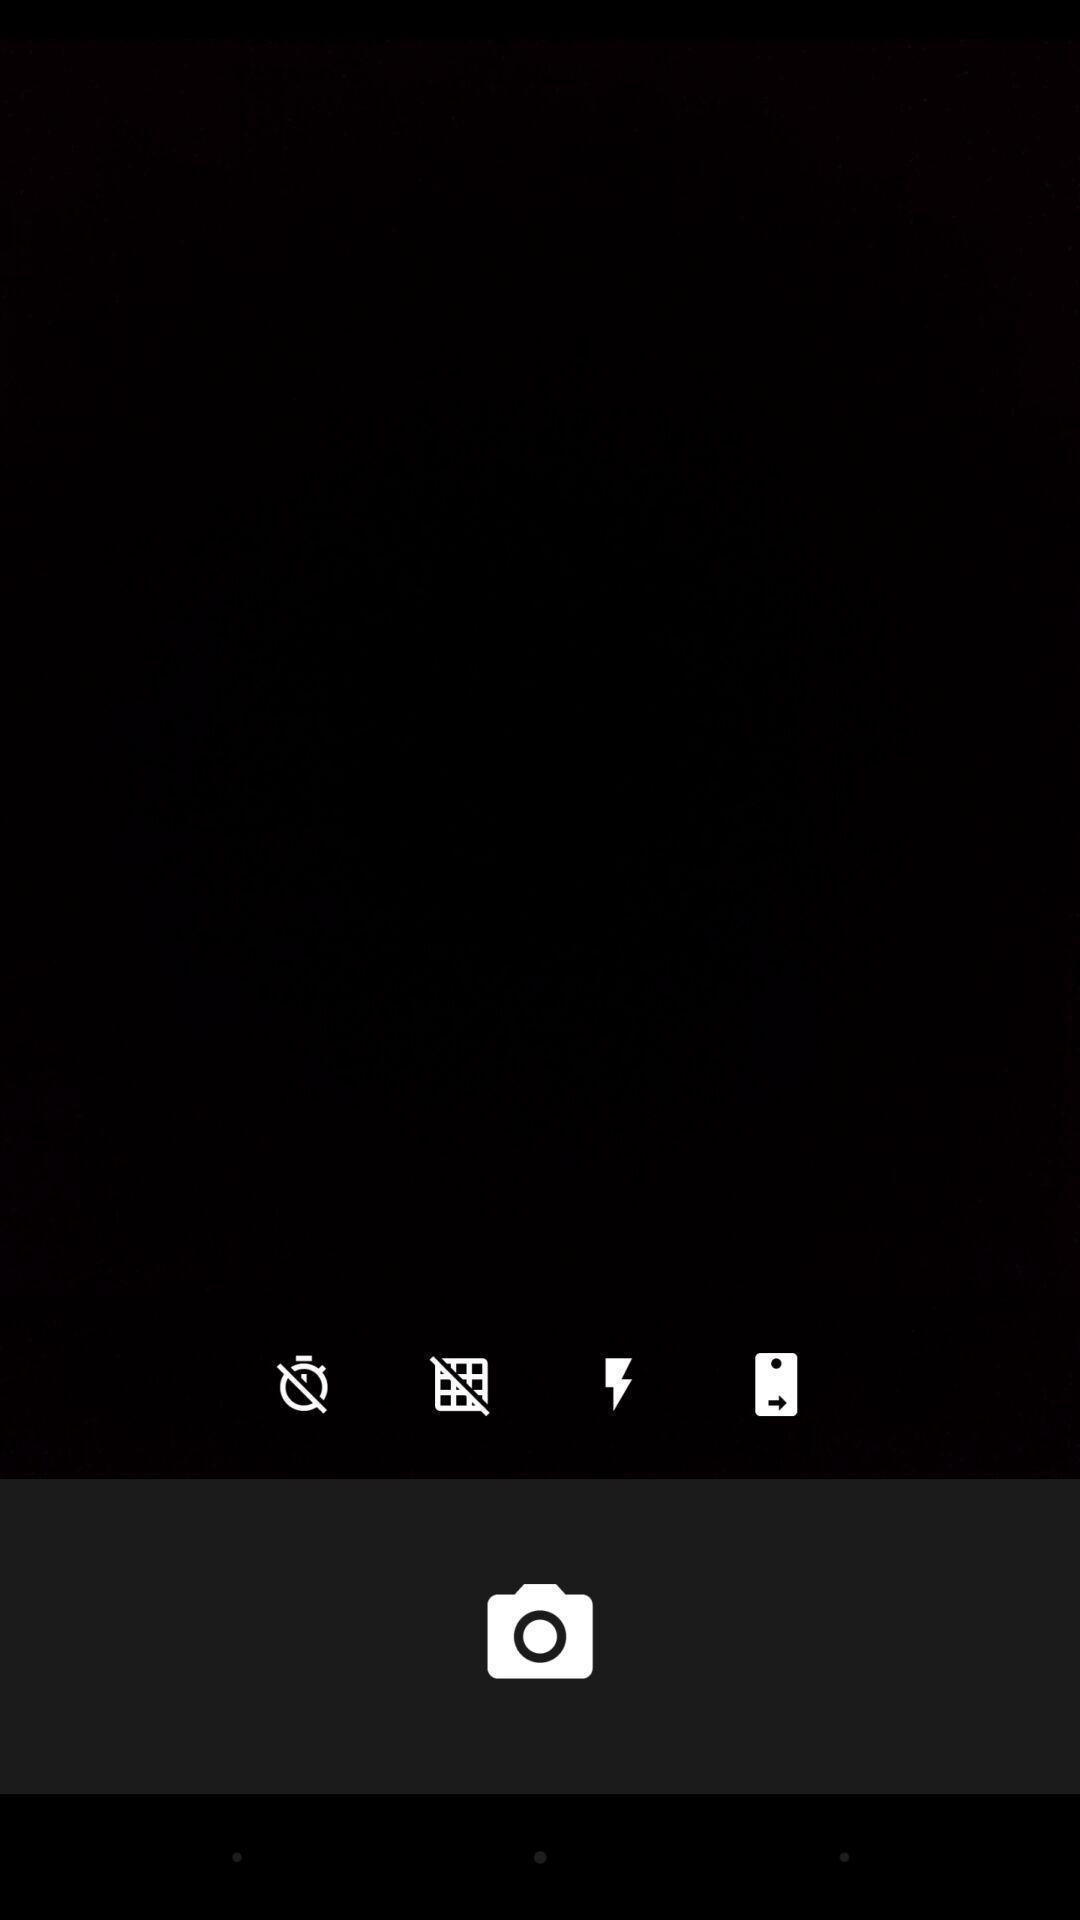Give me a summary of this screen capture. Page showing camera icon with different icons. 